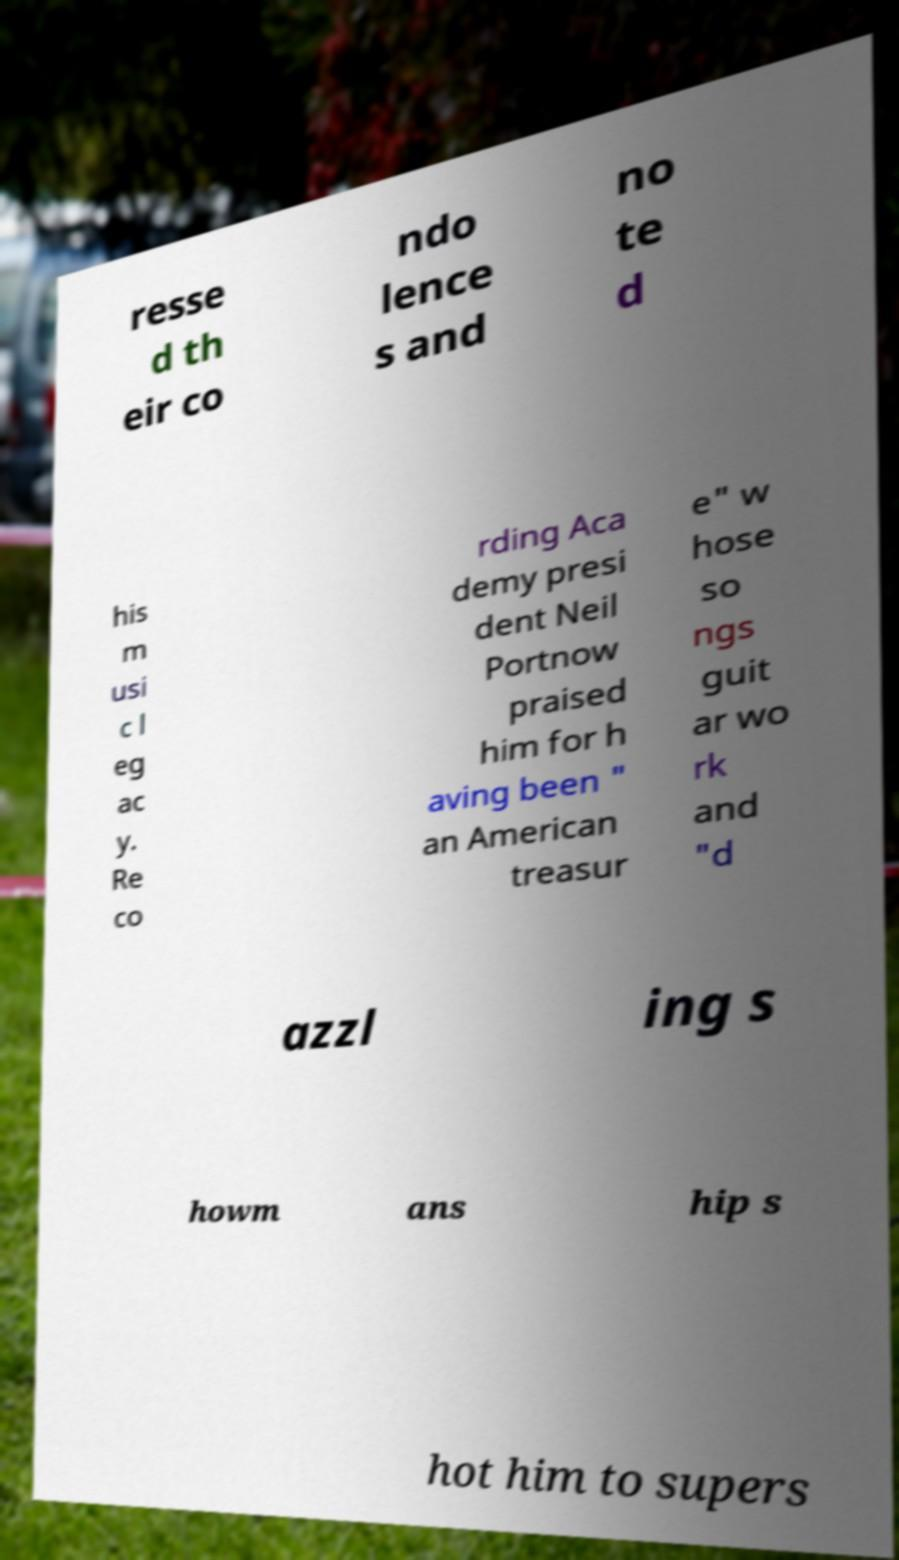Could you extract and type out the text from this image? resse d th eir co ndo lence s and no te d his m usi c l eg ac y. Re co rding Aca demy presi dent Neil Portnow praised him for h aving been " an American treasur e" w hose so ngs guit ar wo rk and "d azzl ing s howm ans hip s hot him to supers 